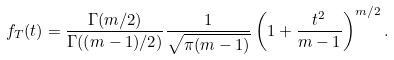Convert formula to latex. <formula><loc_0><loc_0><loc_500><loc_500>f _ { T } ( t ) = { \frac { \Gamma ( m / 2 ) } { \Gamma ( ( m - 1 ) / 2 ) } } { \frac { 1 } { \sqrt { \pi ( m - 1 ) } } } \left ( 1 + { \frac { t ^ { 2 } } { m - 1 } } \right ) ^ { m / 2 } .</formula> 